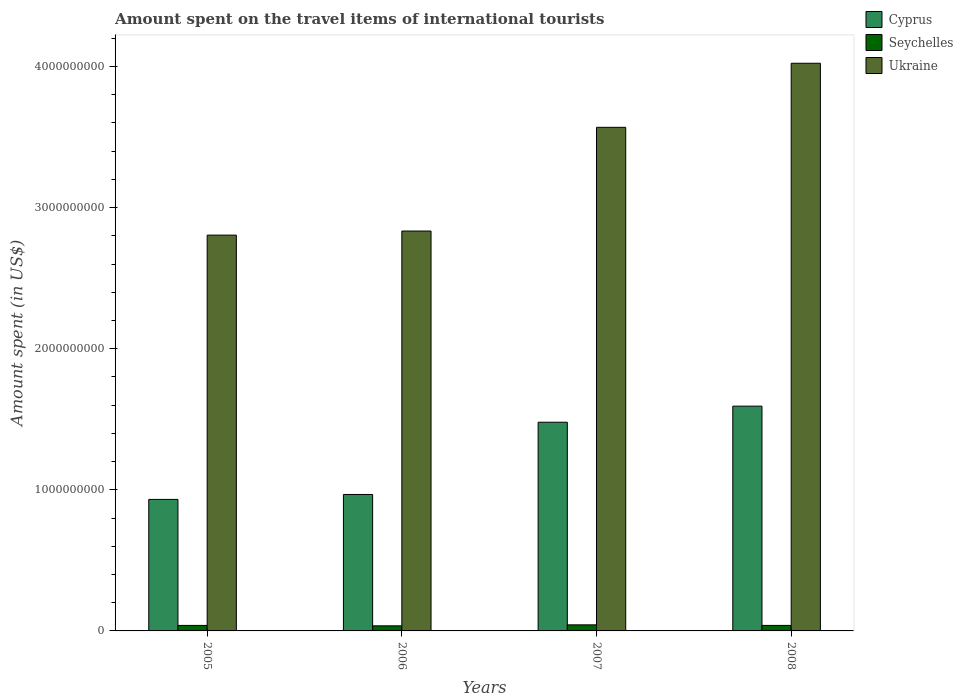How many different coloured bars are there?
Keep it short and to the point. 3. How many groups of bars are there?
Provide a succinct answer. 4. What is the label of the 4th group of bars from the left?
Your response must be concise. 2008. In how many cases, is the number of bars for a given year not equal to the number of legend labels?
Keep it short and to the point. 0. What is the amount spent on the travel items of international tourists in Cyprus in 2007?
Your response must be concise. 1.48e+09. Across all years, what is the maximum amount spent on the travel items of international tourists in Cyprus?
Your answer should be compact. 1.59e+09. Across all years, what is the minimum amount spent on the travel items of international tourists in Ukraine?
Give a very brief answer. 2.80e+09. In which year was the amount spent on the travel items of international tourists in Cyprus minimum?
Provide a short and direct response. 2005. What is the total amount spent on the travel items of international tourists in Seychelles in the graph?
Offer a very short reply. 1.57e+08. What is the difference between the amount spent on the travel items of international tourists in Ukraine in 2005 and that in 2008?
Offer a very short reply. -1.22e+09. What is the difference between the amount spent on the travel items of international tourists in Seychelles in 2007 and the amount spent on the travel items of international tourists in Cyprus in 2006?
Your answer should be very brief. -9.24e+08. What is the average amount spent on the travel items of international tourists in Ukraine per year?
Provide a succinct answer. 3.31e+09. In the year 2008, what is the difference between the amount spent on the travel items of international tourists in Cyprus and amount spent on the travel items of international tourists in Ukraine?
Provide a short and direct response. -2.43e+09. In how many years, is the amount spent on the travel items of international tourists in Ukraine greater than 1400000000 US$?
Your answer should be very brief. 4. What is the ratio of the amount spent on the travel items of international tourists in Ukraine in 2005 to that in 2007?
Your answer should be very brief. 0.79. Is the difference between the amount spent on the travel items of international tourists in Cyprus in 2005 and 2006 greater than the difference between the amount spent on the travel items of international tourists in Ukraine in 2005 and 2006?
Provide a succinct answer. No. What is the difference between the highest and the second highest amount spent on the travel items of international tourists in Ukraine?
Offer a very short reply. 4.54e+08. What is the difference between the highest and the lowest amount spent on the travel items of international tourists in Ukraine?
Ensure brevity in your answer.  1.22e+09. What does the 3rd bar from the left in 2005 represents?
Keep it short and to the point. Ukraine. What does the 2nd bar from the right in 2008 represents?
Your answer should be very brief. Seychelles. How many bars are there?
Give a very brief answer. 12. How many years are there in the graph?
Give a very brief answer. 4. What is the difference between two consecutive major ticks on the Y-axis?
Keep it short and to the point. 1.00e+09. Are the values on the major ticks of Y-axis written in scientific E-notation?
Provide a short and direct response. No. Does the graph contain grids?
Provide a short and direct response. No. How are the legend labels stacked?
Offer a very short reply. Vertical. What is the title of the graph?
Your answer should be compact. Amount spent on the travel items of international tourists. Does "Costa Rica" appear as one of the legend labels in the graph?
Give a very brief answer. No. What is the label or title of the Y-axis?
Offer a terse response. Amount spent (in US$). What is the Amount spent (in US$) of Cyprus in 2005?
Offer a terse response. 9.32e+08. What is the Amount spent (in US$) of Seychelles in 2005?
Offer a terse response. 3.90e+07. What is the Amount spent (in US$) in Ukraine in 2005?
Ensure brevity in your answer.  2.80e+09. What is the Amount spent (in US$) of Cyprus in 2006?
Provide a short and direct response. 9.67e+08. What is the Amount spent (in US$) in Seychelles in 2006?
Make the answer very short. 3.60e+07. What is the Amount spent (in US$) in Ukraine in 2006?
Your answer should be very brief. 2.83e+09. What is the Amount spent (in US$) of Cyprus in 2007?
Your answer should be very brief. 1.48e+09. What is the Amount spent (in US$) of Seychelles in 2007?
Your answer should be very brief. 4.30e+07. What is the Amount spent (in US$) of Ukraine in 2007?
Provide a succinct answer. 3.57e+09. What is the Amount spent (in US$) of Cyprus in 2008?
Make the answer very short. 1.59e+09. What is the Amount spent (in US$) in Seychelles in 2008?
Offer a terse response. 3.90e+07. What is the Amount spent (in US$) in Ukraine in 2008?
Offer a very short reply. 4.02e+09. Across all years, what is the maximum Amount spent (in US$) in Cyprus?
Your answer should be very brief. 1.59e+09. Across all years, what is the maximum Amount spent (in US$) in Seychelles?
Your answer should be very brief. 4.30e+07. Across all years, what is the maximum Amount spent (in US$) in Ukraine?
Your answer should be very brief. 4.02e+09. Across all years, what is the minimum Amount spent (in US$) in Cyprus?
Offer a very short reply. 9.32e+08. Across all years, what is the minimum Amount spent (in US$) of Seychelles?
Provide a succinct answer. 3.60e+07. Across all years, what is the minimum Amount spent (in US$) of Ukraine?
Provide a short and direct response. 2.80e+09. What is the total Amount spent (in US$) in Cyprus in the graph?
Provide a short and direct response. 4.97e+09. What is the total Amount spent (in US$) of Seychelles in the graph?
Your response must be concise. 1.57e+08. What is the total Amount spent (in US$) in Ukraine in the graph?
Provide a succinct answer. 1.32e+1. What is the difference between the Amount spent (in US$) of Cyprus in 2005 and that in 2006?
Ensure brevity in your answer.  -3.50e+07. What is the difference between the Amount spent (in US$) in Seychelles in 2005 and that in 2006?
Provide a succinct answer. 3.00e+06. What is the difference between the Amount spent (in US$) in Ukraine in 2005 and that in 2006?
Your response must be concise. -2.90e+07. What is the difference between the Amount spent (in US$) of Cyprus in 2005 and that in 2007?
Offer a very short reply. -5.47e+08. What is the difference between the Amount spent (in US$) of Ukraine in 2005 and that in 2007?
Ensure brevity in your answer.  -7.64e+08. What is the difference between the Amount spent (in US$) in Cyprus in 2005 and that in 2008?
Give a very brief answer. -6.61e+08. What is the difference between the Amount spent (in US$) in Seychelles in 2005 and that in 2008?
Provide a succinct answer. 0. What is the difference between the Amount spent (in US$) of Ukraine in 2005 and that in 2008?
Give a very brief answer. -1.22e+09. What is the difference between the Amount spent (in US$) in Cyprus in 2006 and that in 2007?
Your answer should be very brief. -5.12e+08. What is the difference between the Amount spent (in US$) in Seychelles in 2006 and that in 2007?
Your answer should be very brief. -7.00e+06. What is the difference between the Amount spent (in US$) of Ukraine in 2006 and that in 2007?
Your response must be concise. -7.35e+08. What is the difference between the Amount spent (in US$) in Cyprus in 2006 and that in 2008?
Keep it short and to the point. -6.26e+08. What is the difference between the Amount spent (in US$) of Ukraine in 2006 and that in 2008?
Your answer should be very brief. -1.19e+09. What is the difference between the Amount spent (in US$) of Cyprus in 2007 and that in 2008?
Your response must be concise. -1.14e+08. What is the difference between the Amount spent (in US$) of Ukraine in 2007 and that in 2008?
Your answer should be very brief. -4.54e+08. What is the difference between the Amount spent (in US$) in Cyprus in 2005 and the Amount spent (in US$) in Seychelles in 2006?
Make the answer very short. 8.96e+08. What is the difference between the Amount spent (in US$) in Cyprus in 2005 and the Amount spent (in US$) in Ukraine in 2006?
Provide a succinct answer. -1.90e+09. What is the difference between the Amount spent (in US$) in Seychelles in 2005 and the Amount spent (in US$) in Ukraine in 2006?
Give a very brief answer. -2.80e+09. What is the difference between the Amount spent (in US$) of Cyprus in 2005 and the Amount spent (in US$) of Seychelles in 2007?
Ensure brevity in your answer.  8.89e+08. What is the difference between the Amount spent (in US$) in Cyprus in 2005 and the Amount spent (in US$) in Ukraine in 2007?
Your answer should be very brief. -2.64e+09. What is the difference between the Amount spent (in US$) in Seychelles in 2005 and the Amount spent (in US$) in Ukraine in 2007?
Give a very brief answer. -3.53e+09. What is the difference between the Amount spent (in US$) in Cyprus in 2005 and the Amount spent (in US$) in Seychelles in 2008?
Give a very brief answer. 8.93e+08. What is the difference between the Amount spent (in US$) in Cyprus in 2005 and the Amount spent (in US$) in Ukraine in 2008?
Provide a short and direct response. -3.09e+09. What is the difference between the Amount spent (in US$) of Seychelles in 2005 and the Amount spent (in US$) of Ukraine in 2008?
Your answer should be very brief. -3.98e+09. What is the difference between the Amount spent (in US$) of Cyprus in 2006 and the Amount spent (in US$) of Seychelles in 2007?
Offer a terse response. 9.24e+08. What is the difference between the Amount spent (in US$) in Cyprus in 2006 and the Amount spent (in US$) in Ukraine in 2007?
Your response must be concise. -2.60e+09. What is the difference between the Amount spent (in US$) of Seychelles in 2006 and the Amount spent (in US$) of Ukraine in 2007?
Provide a succinct answer. -3.53e+09. What is the difference between the Amount spent (in US$) in Cyprus in 2006 and the Amount spent (in US$) in Seychelles in 2008?
Keep it short and to the point. 9.28e+08. What is the difference between the Amount spent (in US$) in Cyprus in 2006 and the Amount spent (in US$) in Ukraine in 2008?
Keep it short and to the point. -3.06e+09. What is the difference between the Amount spent (in US$) of Seychelles in 2006 and the Amount spent (in US$) of Ukraine in 2008?
Provide a short and direct response. -3.99e+09. What is the difference between the Amount spent (in US$) in Cyprus in 2007 and the Amount spent (in US$) in Seychelles in 2008?
Keep it short and to the point. 1.44e+09. What is the difference between the Amount spent (in US$) of Cyprus in 2007 and the Amount spent (in US$) of Ukraine in 2008?
Offer a very short reply. -2.54e+09. What is the difference between the Amount spent (in US$) of Seychelles in 2007 and the Amount spent (in US$) of Ukraine in 2008?
Keep it short and to the point. -3.98e+09. What is the average Amount spent (in US$) in Cyprus per year?
Your answer should be compact. 1.24e+09. What is the average Amount spent (in US$) of Seychelles per year?
Your answer should be very brief. 3.92e+07. What is the average Amount spent (in US$) of Ukraine per year?
Offer a very short reply. 3.31e+09. In the year 2005, what is the difference between the Amount spent (in US$) in Cyprus and Amount spent (in US$) in Seychelles?
Make the answer very short. 8.93e+08. In the year 2005, what is the difference between the Amount spent (in US$) of Cyprus and Amount spent (in US$) of Ukraine?
Ensure brevity in your answer.  -1.87e+09. In the year 2005, what is the difference between the Amount spent (in US$) in Seychelles and Amount spent (in US$) in Ukraine?
Your response must be concise. -2.77e+09. In the year 2006, what is the difference between the Amount spent (in US$) of Cyprus and Amount spent (in US$) of Seychelles?
Provide a short and direct response. 9.31e+08. In the year 2006, what is the difference between the Amount spent (in US$) of Cyprus and Amount spent (in US$) of Ukraine?
Offer a very short reply. -1.87e+09. In the year 2006, what is the difference between the Amount spent (in US$) in Seychelles and Amount spent (in US$) in Ukraine?
Make the answer very short. -2.80e+09. In the year 2007, what is the difference between the Amount spent (in US$) in Cyprus and Amount spent (in US$) in Seychelles?
Make the answer very short. 1.44e+09. In the year 2007, what is the difference between the Amount spent (in US$) of Cyprus and Amount spent (in US$) of Ukraine?
Ensure brevity in your answer.  -2.09e+09. In the year 2007, what is the difference between the Amount spent (in US$) in Seychelles and Amount spent (in US$) in Ukraine?
Offer a terse response. -3.53e+09. In the year 2008, what is the difference between the Amount spent (in US$) of Cyprus and Amount spent (in US$) of Seychelles?
Ensure brevity in your answer.  1.55e+09. In the year 2008, what is the difference between the Amount spent (in US$) of Cyprus and Amount spent (in US$) of Ukraine?
Provide a short and direct response. -2.43e+09. In the year 2008, what is the difference between the Amount spent (in US$) in Seychelles and Amount spent (in US$) in Ukraine?
Ensure brevity in your answer.  -3.98e+09. What is the ratio of the Amount spent (in US$) of Cyprus in 2005 to that in 2006?
Provide a succinct answer. 0.96. What is the ratio of the Amount spent (in US$) of Ukraine in 2005 to that in 2006?
Provide a short and direct response. 0.99. What is the ratio of the Amount spent (in US$) of Cyprus in 2005 to that in 2007?
Your response must be concise. 0.63. What is the ratio of the Amount spent (in US$) in Seychelles in 2005 to that in 2007?
Your response must be concise. 0.91. What is the ratio of the Amount spent (in US$) in Ukraine in 2005 to that in 2007?
Make the answer very short. 0.79. What is the ratio of the Amount spent (in US$) of Cyprus in 2005 to that in 2008?
Your answer should be compact. 0.59. What is the ratio of the Amount spent (in US$) of Ukraine in 2005 to that in 2008?
Provide a succinct answer. 0.7. What is the ratio of the Amount spent (in US$) of Cyprus in 2006 to that in 2007?
Your answer should be very brief. 0.65. What is the ratio of the Amount spent (in US$) in Seychelles in 2006 to that in 2007?
Ensure brevity in your answer.  0.84. What is the ratio of the Amount spent (in US$) in Ukraine in 2006 to that in 2007?
Provide a short and direct response. 0.79. What is the ratio of the Amount spent (in US$) of Cyprus in 2006 to that in 2008?
Provide a short and direct response. 0.61. What is the ratio of the Amount spent (in US$) of Ukraine in 2006 to that in 2008?
Your answer should be very brief. 0.7. What is the ratio of the Amount spent (in US$) of Cyprus in 2007 to that in 2008?
Offer a terse response. 0.93. What is the ratio of the Amount spent (in US$) in Seychelles in 2007 to that in 2008?
Provide a short and direct response. 1.1. What is the ratio of the Amount spent (in US$) in Ukraine in 2007 to that in 2008?
Offer a terse response. 0.89. What is the difference between the highest and the second highest Amount spent (in US$) in Cyprus?
Your answer should be compact. 1.14e+08. What is the difference between the highest and the second highest Amount spent (in US$) in Seychelles?
Provide a succinct answer. 4.00e+06. What is the difference between the highest and the second highest Amount spent (in US$) in Ukraine?
Give a very brief answer. 4.54e+08. What is the difference between the highest and the lowest Amount spent (in US$) of Cyprus?
Give a very brief answer. 6.61e+08. What is the difference between the highest and the lowest Amount spent (in US$) of Ukraine?
Provide a succinct answer. 1.22e+09. 